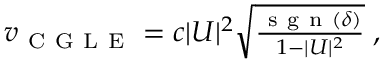<formula> <loc_0><loc_0><loc_500><loc_500>\begin{array} { r } { v _ { C G L E } = c | U | ^ { 2 } \sqrt { \frac { s g n ( \delta ) } { 1 - | U | ^ { 2 } } } \, , } \end{array}</formula> 